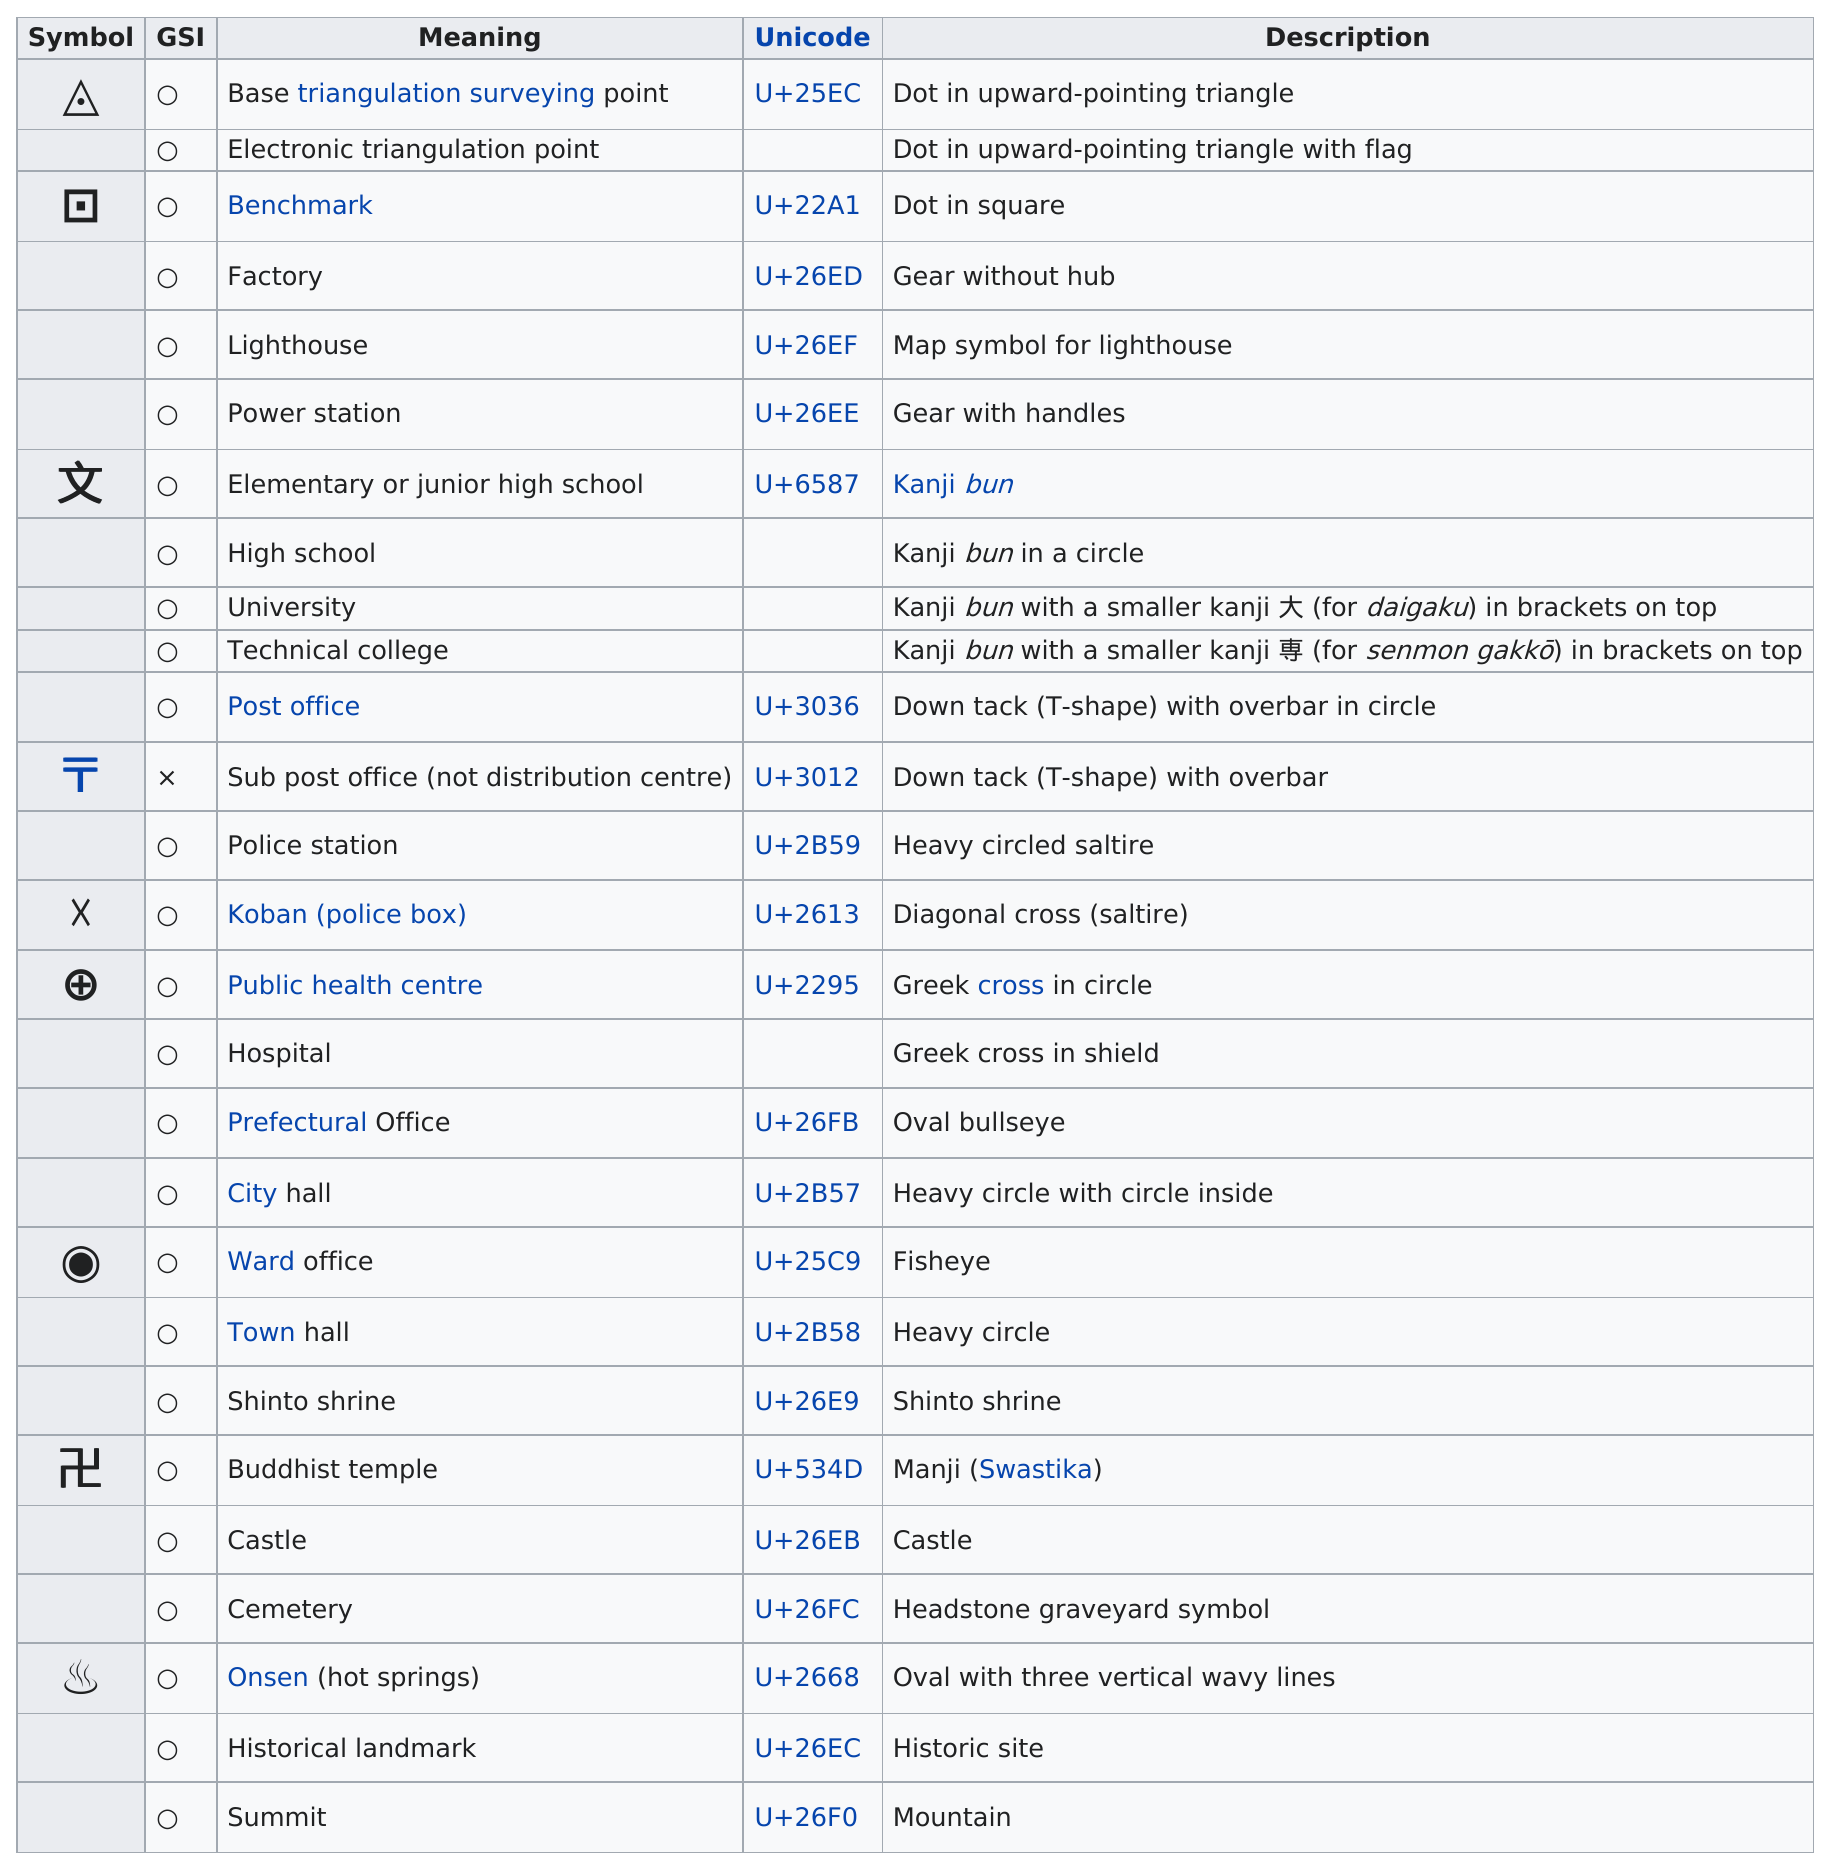Draw attention to some important aspects in this diagram. In total, 24 symbols are shown. The upward pointing triangle is a part of the total number of symbols used in 2... The emoji with a Unicode value of u+22a1, commonly known as the benchmark symbol or the factory symbol, is being used in the benchmark section of the application. Please confirm which symbol should be used. The sub post office uses a symbol with a t-shape that is not as big as the post office itself. There are 22 unique characters in the list. 